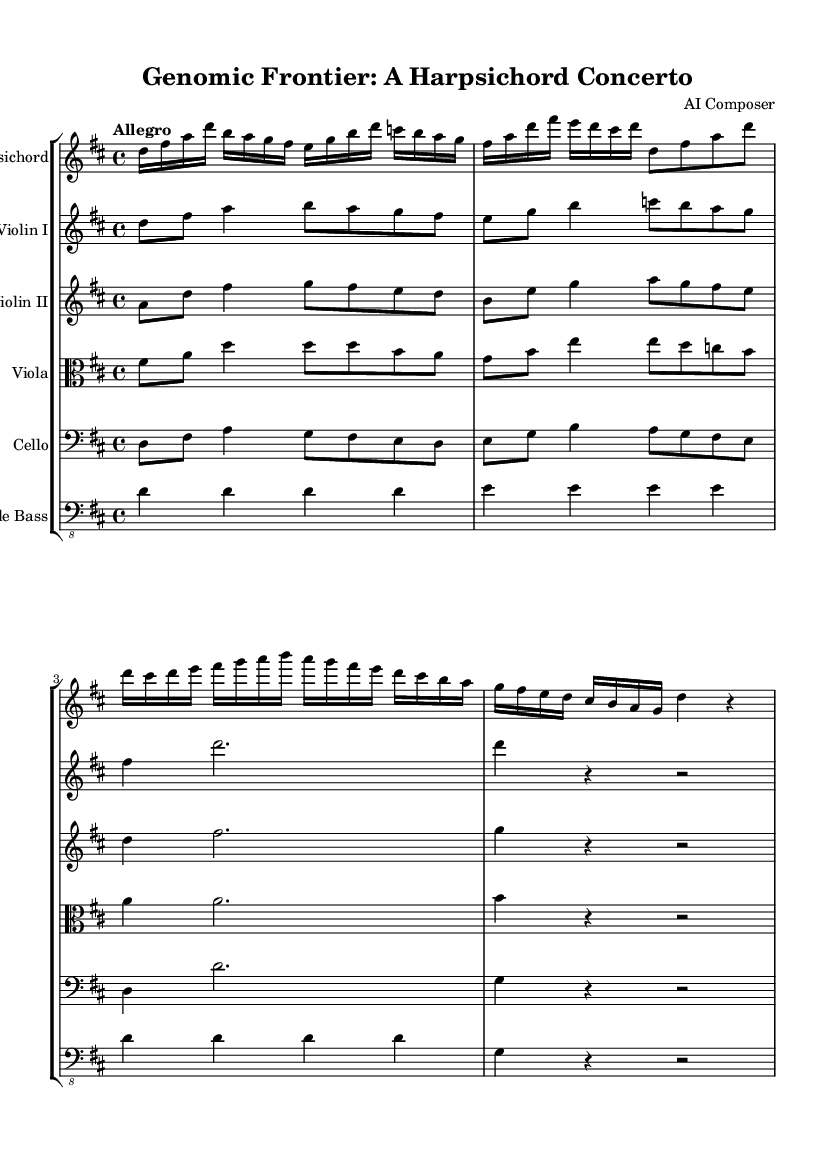What is the key signature of this music? The key signature shown at the beginning of the sheet music is D major, identified by the two sharps (F# and C#) indicated on the staff.
Answer: D major What is the time signature of this music? The time signature is indicated by the "4/4" notation at the beginning of the score, meaning there are four beats per measure and the quarter note gets one beat.
Answer: 4/4 What tempo marking is indicated in the score? The tempo marking "Allegro" is noted at the beginning, indicating that the piece should be played at a fast, lively tempo.
Answer: Allegro How many instruments are featured in this concerto? By counting the separate staves in the score, there are a total of six distinct instruments represented.
Answer: Six Which instrument is labeled first in the score? The first instrument labeled in the score is the Harpsichord, which is indicated as the primary solo instrument for this concerto.
Answer: Harpsichord What is the rhythmic pattern primarily used in the Harpsichord part? The Harpsichord part prominently features a mix of sixteenth notes and longer notes like eighth and quarter notes. This creates a lively character typical of Baroque concertos.
Answer: Sixteenth notes What common feature of Baroque music is present in the interaction between the instruments? The score exhibits a polyphonic texture, characterized by multiple independent melody lines, which is a hallmark of Baroque composition style.
Answer: Polyphonic 